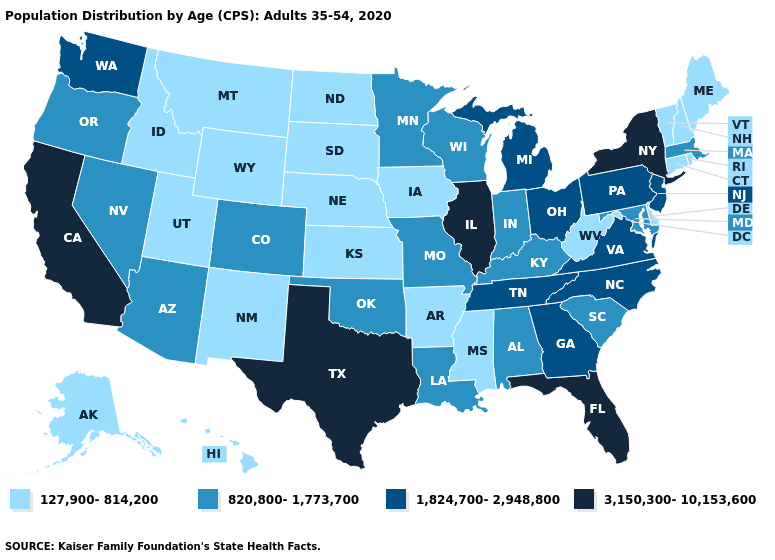Name the states that have a value in the range 1,824,700-2,948,800?
Quick response, please. Georgia, Michigan, New Jersey, North Carolina, Ohio, Pennsylvania, Tennessee, Virginia, Washington. Name the states that have a value in the range 3,150,300-10,153,600?
Keep it brief. California, Florida, Illinois, New York, Texas. Does Wisconsin have a lower value than Oklahoma?
Keep it brief. No. Name the states that have a value in the range 127,900-814,200?
Answer briefly. Alaska, Arkansas, Connecticut, Delaware, Hawaii, Idaho, Iowa, Kansas, Maine, Mississippi, Montana, Nebraska, New Hampshire, New Mexico, North Dakota, Rhode Island, South Dakota, Utah, Vermont, West Virginia, Wyoming. What is the value of Massachusetts?
Keep it brief. 820,800-1,773,700. Name the states that have a value in the range 127,900-814,200?
Quick response, please. Alaska, Arkansas, Connecticut, Delaware, Hawaii, Idaho, Iowa, Kansas, Maine, Mississippi, Montana, Nebraska, New Hampshire, New Mexico, North Dakota, Rhode Island, South Dakota, Utah, Vermont, West Virginia, Wyoming. Does Maryland have the same value as Oklahoma?
Write a very short answer. Yes. Name the states that have a value in the range 127,900-814,200?
Quick response, please. Alaska, Arkansas, Connecticut, Delaware, Hawaii, Idaho, Iowa, Kansas, Maine, Mississippi, Montana, Nebraska, New Hampshire, New Mexico, North Dakota, Rhode Island, South Dakota, Utah, Vermont, West Virginia, Wyoming. What is the value of Oregon?
Quick response, please. 820,800-1,773,700. Does Massachusetts have a lower value than Tennessee?
Give a very brief answer. Yes. Among the states that border Iowa , which have the lowest value?
Be succinct. Nebraska, South Dakota. Name the states that have a value in the range 3,150,300-10,153,600?
Concise answer only. California, Florida, Illinois, New York, Texas. What is the highest value in the USA?
Write a very short answer. 3,150,300-10,153,600. What is the lowest value in the USA?
Short answer required. 127,900-814,200. What is the lowest value in states that border Massachusetts?
Give a very brief answer. 127,900-814,200. 